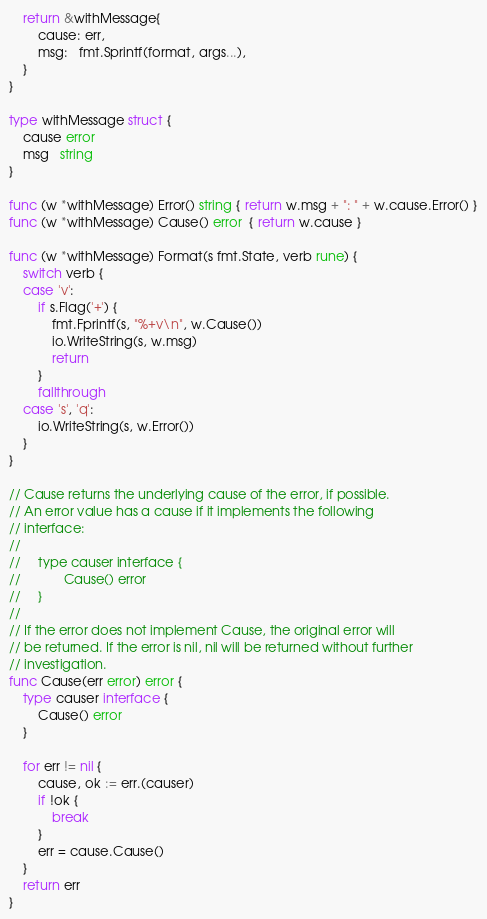<code> <loc_0><loc_0><loc_500><loc_500><_Go_>	return &withMessage{
		cause: err,
		msg:   fmt.Sprintf(format, args...),
	}
}

type withMessage struct {
	cause error
	msg   string
}

func (w *withMessage) Error() string { return w.msg + ": " + w.cause.Error() }
func (w *withMessage) Cause() error  { return w.cause }

func (w *withMessage) Format(s fmt.State, verb rune) {
	switch verb {
	case 'v':
		if s.Flag('+') {
			fmt.Fprintf(s, "%+v\n", w.Cause())
			io.WriteString(s, w.msg)
			return
		}
		fallthrough
	case 's', 'q':
		io.WriteString(s, w.Error())
	}
}

// Cause returns the underlying cause of the error, if possible.
// An error value has a cause if it implements the following
// interface:
//
//     type causer interface {
//            Cause() error
//     }
//
// If the error does not implement Cause, the original error will
// be returned. If the error is nil, nil will be returned without further
// investigation.
func Cause(err error) error {
	type causer interface {
		Cause() error
	}

	for err != nil {
		cause, ok := err.(causer)
		if !ok {
			break
		}
		err = cause.Cause()
	}
	return err
}
</code> 